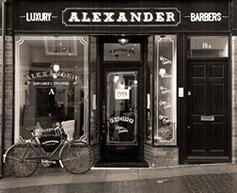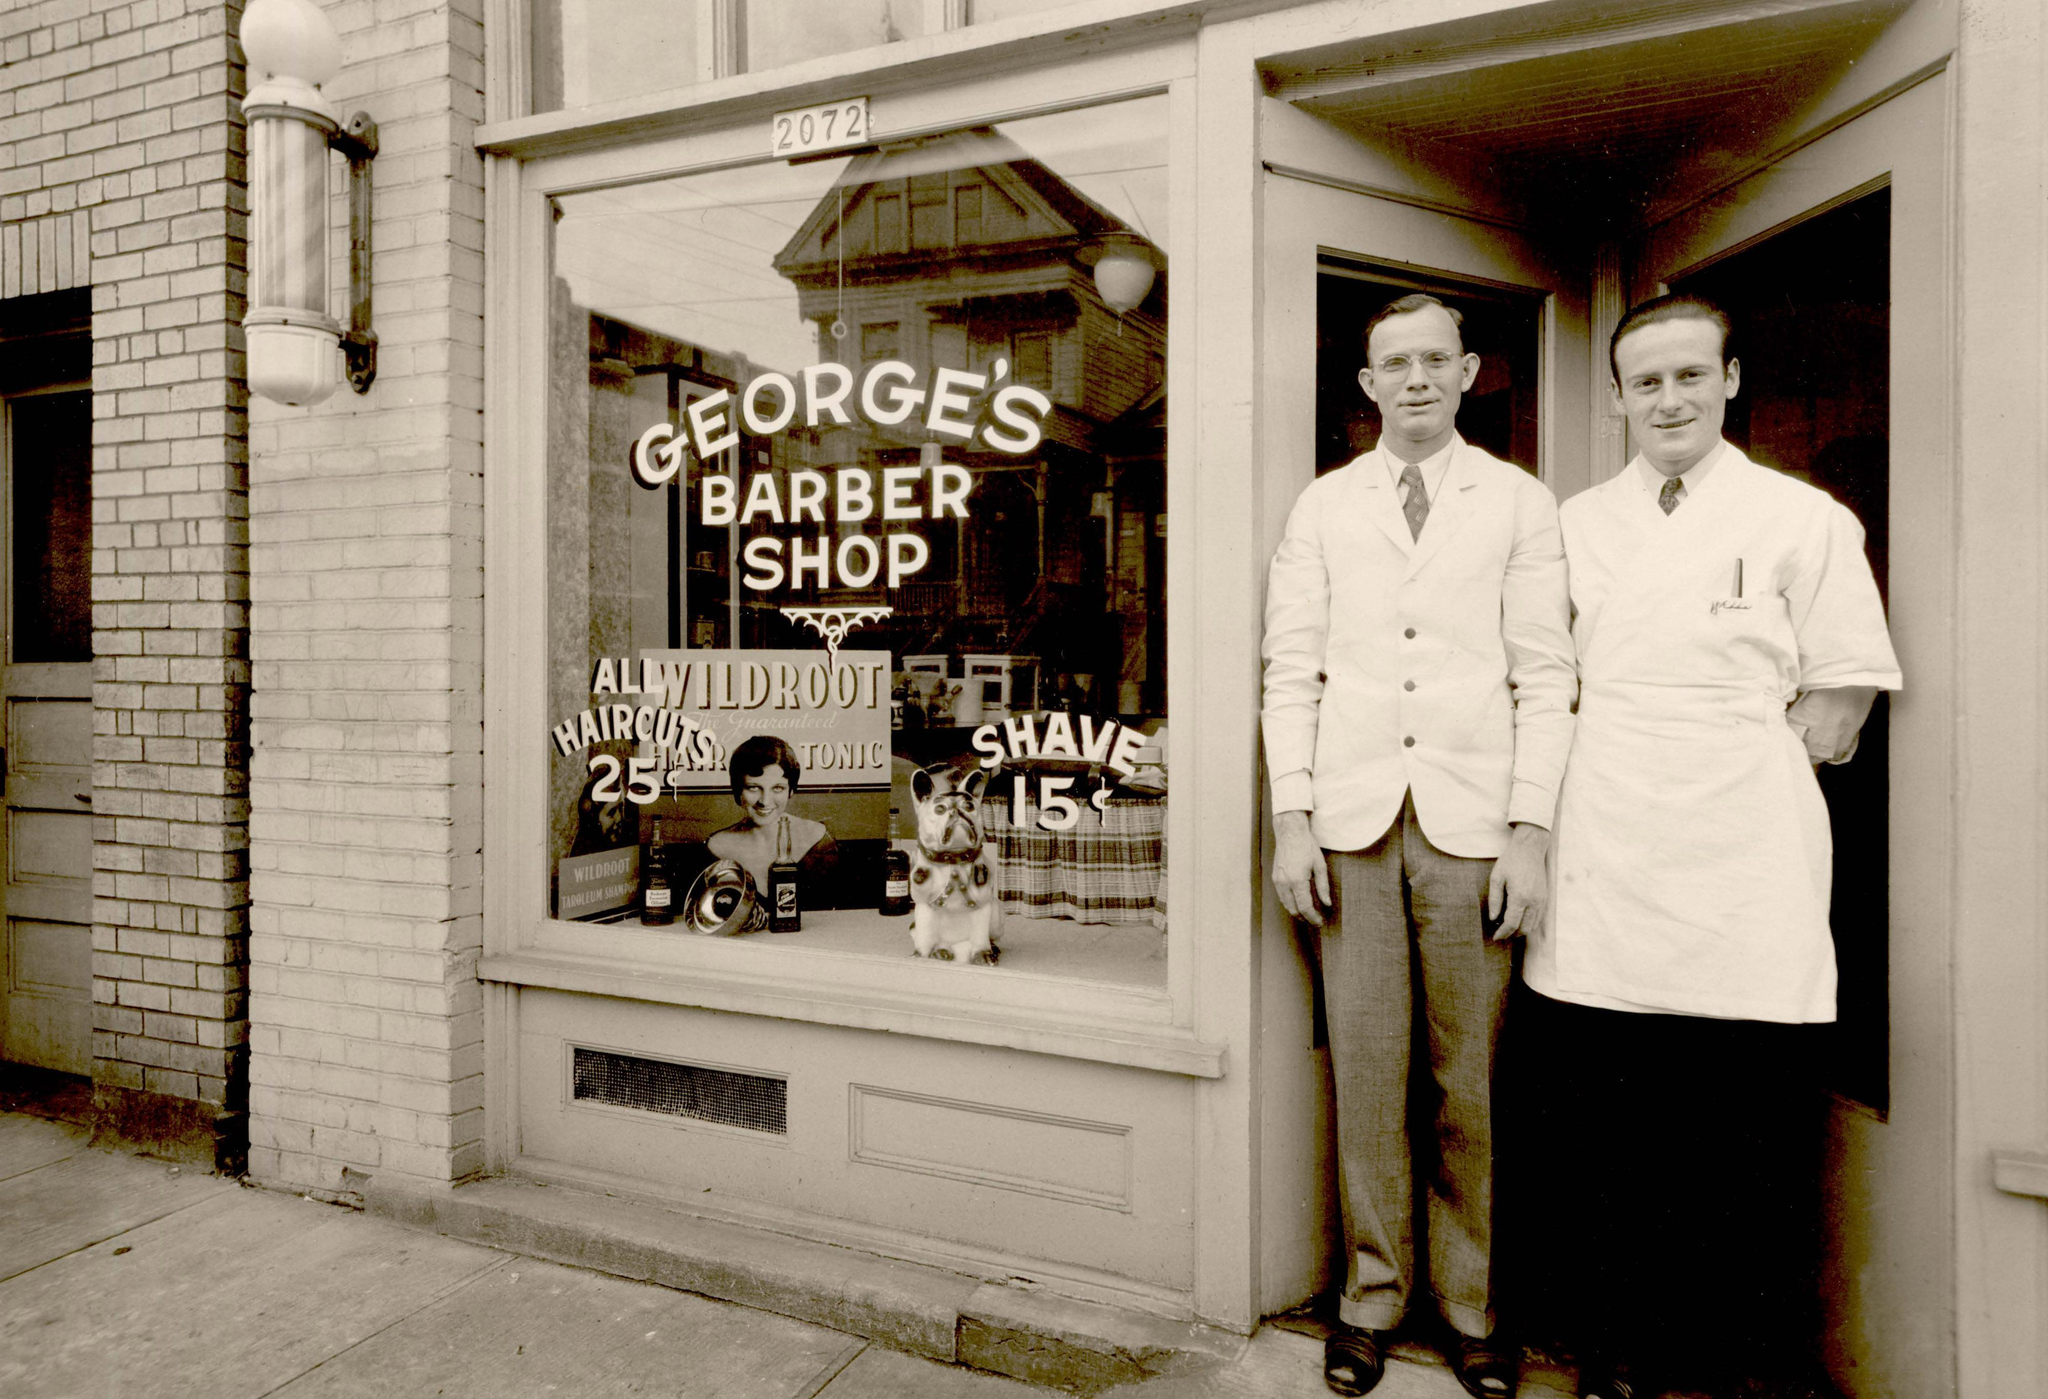The first image is the image on the left, the second image is the image on the right. For the images displayed, is the sentence "Each barber shop displays at least one barber pole." factually correct? Answer yes or no. No. 